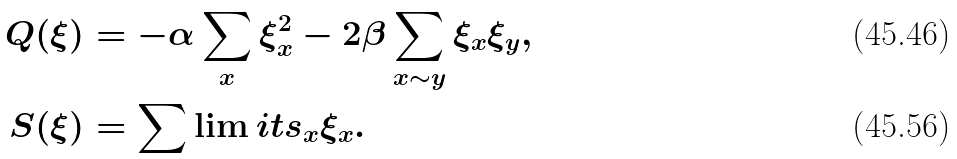<formula> <loc_0><loc_0><loc_500><loc_500>Q ( \xi ) & = - \alpha \sum _ { x } \xi ^ { 2 } _ { x } - 2 \beta \sum _ { x \sim y } \xi _ { x } \xi _ { y } , \\ S ( \xi ) & = \sum \lim i t s _ { x } \xi _ { x } .</formula> 